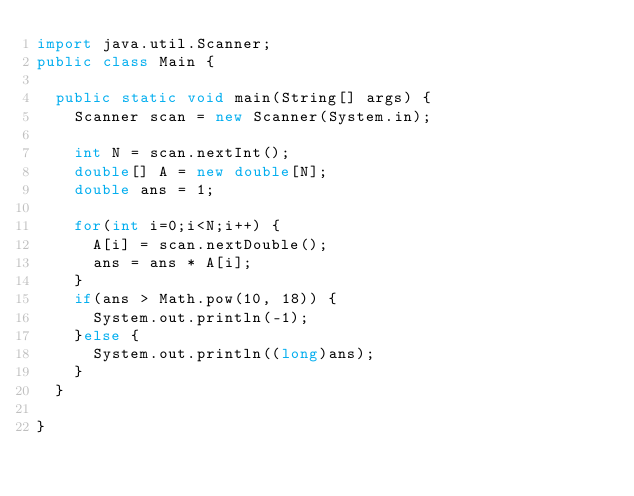Convert code to text. <code><loc_0><loc_0><loc_500><loc_500><_Java_>import java.util.Scanner;
public class Main {

	public static void main(String[] args) {
		Scanner scan = new Scanner(System.in);
		
		int N = scan.nextInt();
		double[] A = new double[N];
		double ans = 1;
		
		for(int i=0;i<N;i++) {
			A[i] = scan.nextDouble();
			ans = ans * A[i];
		}
		if(ans > Math.pow(10, 18)) {
			System.out.println(-1);
		}else {
			System.out.println((long)ans);
		}
	}

}
</code> 